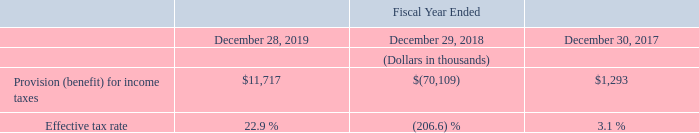Provision (Benefit) For Income Taxes
Provision for income taxes reflects the tax provision on our operations in foreign and U.S. jurisdictions, offset by tax benefits from a partial release of valuation allowance against U.S. federal and state deferred tax assets ("DTAs") and from lapsing of statute of limitations related to uncertain tax positions in foreign jurisdictions. As of December 28, 2019, we maintain a valuation allowance of $36.6 million primarily against our California deferred tax assets and foreign tax credits, due to uncertainty about the future realization of these assets.
The benefit for income taxes in fiscal 2018 includes a $75.8 million reduction to our valuation allowance on our U.S. deferred tax assets as sufficient positive evidence existed to support the realization of such DTAs. The effective tax rate in fiscal 2018 also benefited from a lower statutory tax rate in the U.S., partially offset by higher profits in foreign jurisdictions.
Our effective tax rate may vary from period to period based on changes in estimated taxable income or loss by jurisdiction, changes to the valuation allowance, changes to U.S. federal, state or foreign tax laws, future expansion into areas with varying country, state, and local income tax rates, deductibility of certain costs and expenses by jurisdiction.
How much is the valuation allowance maintained As of December 28, 2019? $36.6 million. What is the change in Provision (benefit) for income taxes from Fiscal Year Ended December 28, 2019 to December 29, 2018?
Answer scale should be: thousand. 11,717-(70,109)
Answer: 81826. What is the change in Provision (benefit) for income taxes from Fiscal Year Ended December 29, 2018 to December 30, 2017?
Answer scale should be: thousand. (70,109)-1,293
Answer: -71402. In which year was Provision (benefit) for income taxes greater than 10,000 thousands? Locate and analyze provision (benefit) for income taxes in row 4
answer: 2019. What was the Effective tax rate in 2018 and 2017 respectively?
Answer scale should be: percent. (206.6) %, 3.1 %. What was the reduction to valuation allowance in 2018? $75.8 million. 